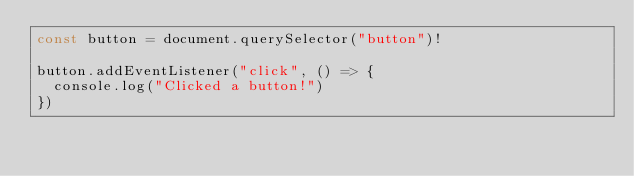<code> <loc_0><loc_0><loc_500><loc_500><_TypeScript_>const button = document.querySelector("button")!

button.addEventListener("click", () => {
  console.log("Clicked a button!")
})
</code> 